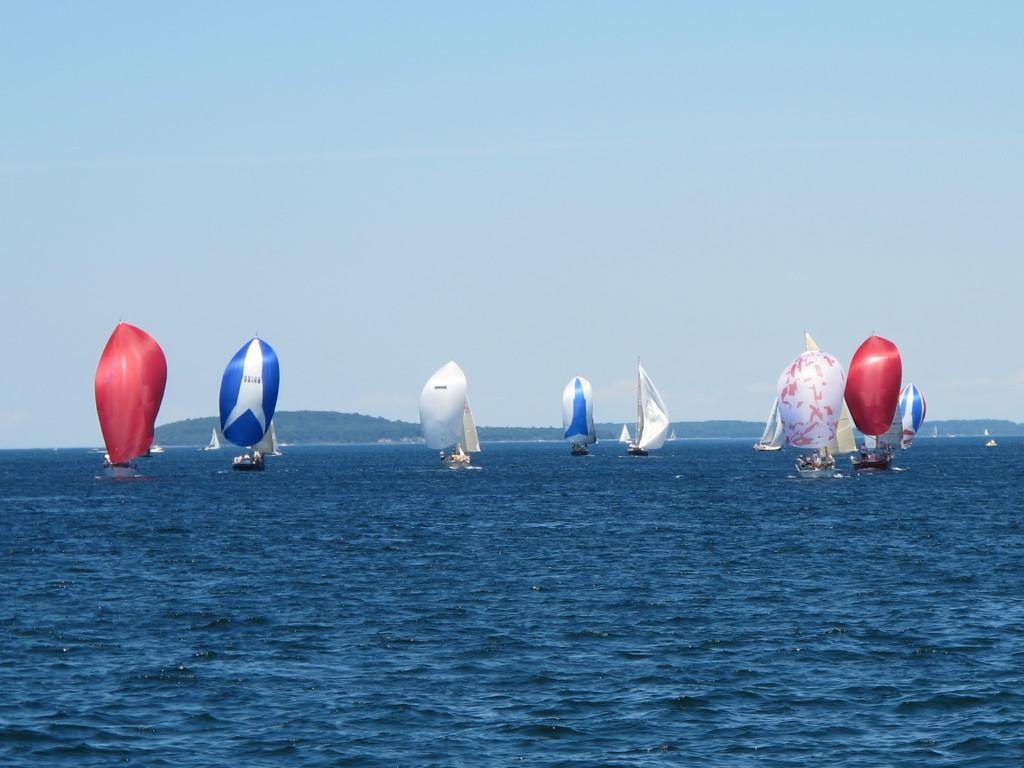What is happening in the image? There are boats sailing in the ocean in the image. Can you describe the sailing clothes worn by the people in the image? The sailing clothes have different colors, including red, white, and blue. What can be seen in the background of the image? There is a sky visible in the background of the image. How much debt is being discussed by the people on the boats in the image? There is no mention of debt or any financial discussions in the image; it features boats sailing in the ocean. Can you see any bats flying around the boats in the image? There are no bats visible in the image; it features boats sailing in the ocean. 